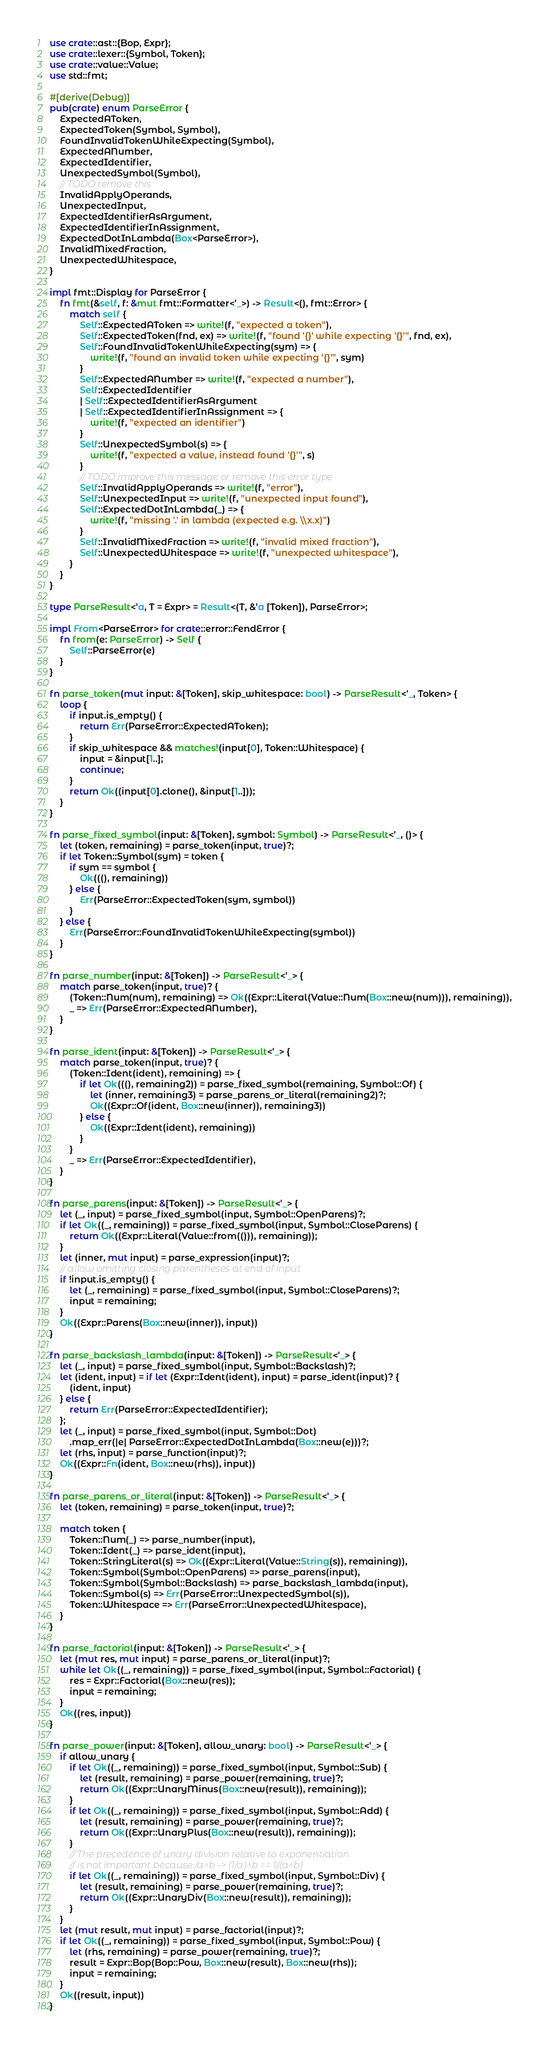Convert code to text. <code><loc_0><loc_0><loc_500><loc_500><_Rust_>use crate::ast::{Bop, Expr};
use crate::lexer::{Symbol, Token};
use crate::value::Value;
use std::fmt;

#[derive(Debug)]
pub(crate) enum ParseError {
    ExpectedAToken,
    ExpectedToken(Symbol, Symbol),
    FoundInvalidTokenWhileExpecting(Symbol),
    ExpectedANumber,
    ExpectedIdentifier,
    UnexpectedSymbol(Symbol),
    // TODO remove this
    InvalidApplyOperands,
    UnexpectedInput,
    ExpectedIdentifierAsArgument,
    ExpectedIdentifierInAssignment,
    ExpectedDotInLambda(Box<ParseError>),
    InvalidMixedFraction,
    UnexpectedWhitespace,
}

impl fmt::Display for ParseError {
    fn fmt(&self, f: &mut fmt::Formatter<'_>) -> Result<(), fmt::Error> {
        match self {
            Self::ExpectedAToken => write!(f, "expected a token"),
            Self::ExpectedToken(fnd, ex) => write!(f, "found '{}' while expecting '{}'", fnd, ex),
            Self::FoundInvalidTokenWhileExpecting(sym) => {
                write!(f, "found an invalid token while expecting '{}'", sym)
            }
            Self::ExpectedANumber => write!(f, "expected a number"),
            Self::ExpectedIdentifier
            | Self::ExpectedIdentifierAsArgument
            | Self::ExpectedIdentifierInAssignment => {
                write!(f, "expected an identifier")
            }
            Self::UnexpectedSymbol(s) => {
                write!(f, "expected a value, instead found '{}'", s)
            }
            // TODO improve this message or remove this error type
            Self::InvalidApplyOperands => write!(f, "error"),
            Self::UnexpectedInput => write!(f, "unexpected input found"),
            Self::ExpectedDotInLambda(_) => {
                write!(f, "missing '.' in lambda (expected e.g. \\x.x)")
            }
            Self::InvalidMixedFraction => write!(f, "invalid mixed fraction"),
            Self::UnexpectedWhitespace => write!(f, "unexpected whitespace"),
        }
    }
}

type ParseResult<'a, T = Expr> = Result<(T, &'a [Token]), ParseError>;

impl From<ParseError> for crate::error::FendError {
    fn from(e: ParseError) -> Self {
        Self::ParseError(e)
    }
}

fn parse_token(mut input: &[Token], skip_whitespace: bool) -> ParseResult<'_, Token> {
    loop {
        if input.is_empty() {
            return Err(ParseError::ExpectedAToken);
        }
        if skip_whitespace && matches!(input[0], Token::Whitespace) {
            input = &input[1..];
            continue;
        }
        return Ok((input[0].clone(), &input[1..]));
    }
}

fn parse_fixed_symbol(input: &[Token], symbol: Symbol) -> ParseResult<'_, ()> {
    let (token, remaining) = parse_token(input, true)?;
    if let Token::Symbol(sym) = token {
        if sym == symbol {
            Ok(((), remaining))
        } else {
            Err(ParseError::ExpectedToken(sym, symbol))
        }
    } else {
        Err(ParseError::FoundInvalidTokenWhileExpecting(symbol))
    }
}

fn parse_number(input: &[Token]) -> ParseResult<'_> {
    match parse_token(input, true)? {
        (Token::Num(num), remaining) => Ok((Expr::Literal(Value::Num(Box::new(num))), remaining)),
        _ => Err(ParseError::ExpectedANumber),
    }
}

fn parse_ident(input: &[Token]) -> ParseResult<'_> {
    match parse_token(input, true)? {
        (Token::Ident(ident), remaining) => {
            if let Ok(((), remaining2)) = parse_fixed_symbol(remaining, Symbol::Of) {
                let (inner, remaining3) = parse_parens_or_literal(remaining2)?;
                Ok((Expr::Of(ident, Box::new(inner)), remaining3))
            } else {
                Ok((Expr::Ident(ident), remaining))
            }
        }
        _ => Err(ParseError::ExpectedIdentifier),
    }
}

fn parse_parens(input: &[Token]) -> ParseResult<'_> {
    let (_, input) = parse_fixed_symbol(input, Symbol::OpenParens)?;
    if let Ok((_, remaining)) = parse_fixed_symbol(input, Symbol::CloseParens) {
        return Ok((Expr::Literal(Value::from(())), remaining));
    }
    let (inner, mut input) = parse_expression(input)?;
    // allow omitting closing parentheses at end of input
    if !input.is_empty() {
        let (_, remaining) = parse_fixed_symbol(input, Symbol::CloseParens)?;
        input = remaining;
    }
    Ok((Expr::Parens(Box::new(inner)), input))
}

fn parse_backslash_lambda(input: &[Token]) -> ParseResult<'_> {
    let (_, input) = parse_fixed_symbol(input, Symbol::Backslash)?;
    let (ident, input) = if let (Expr::Ident(ident), input) = parse_ident(input)? {
        (ident, input)
    } else {
        return Err(ParseError::ExpectedIdentifier);
    };
    let (_, input) = parse_fixed_symbol(input, Symbol::Dot)
        .map_err(|e| ParseError::ExpectedDotInLambda(Box::new(e)))?;
    let (rhs, input) = parse_function(input)?;
    Ok((Expr::Fn(ident, Box::new(rhs)), input))
}

fn parse_parens_or_literal(input: &[Token]) -> ParseResult<'_> {
    let (token, remaining) = parse_token(input, true)?;

    match token {
        Token::Num(_) => parse_number(input),
        Token::Ident(_) => parse_ident(input),
        Token::StringLiteral(s) => Ok((Expr::Literal(Value::String(s)), remaining)),
        Token::Symbol(Symbol::OpenParens) => parse_parens(input),
        Token::Symbol(Symbol::Backslash) => parse_backslash_lambda(input),
        Token::Symbol(s) => Err(ParseError::UnexpectedSymbol(s)),
        Token::Whitespace => Err(ParseError::UnexpectedWhitespace),
    }
}

fn parse_factorial(input: &[Token]) -> ParseResult<'_> {
    let (mut res, mut input) = parse_parens_or_literal(input)?;
    while let Ok((_, remaining)) = parse_fixed_symbol(input, Symbol::Factorial) {
        res = Expr::Factorial(Box::new(res));
        input = remaining;
    }
    Ok((res, input))
}

fn parse_power(input: &[Token], allow_unary: bool) -> ParseResult<'_> {
    if allow_unary {
        if let Ok((_, remaining)) = parse_fixed_symbol(input, Symbol::Sub) {
            let (result, remaining) = parse_power(remaining, true)?;
            return Ok((Expr::UnaryMinus(Box::new(result)), remaining));
        }
        if let Ok((_, remaining)) = parse_fixed_symbol(input, Symbol::Add) {
            let (result, remaining) = parse_power(remaining, true)?;
            return Ok((Expr::UnaryPlus(Box::new(result)), remaining));
        }
        // The precedence of unary division relative to exponentiation
        // is not important because /a^b -> (1/a)^b == 1/(a^b)
        if let Ok((_, remaining)) = parse_fixed_symbol(input, Symbol::Div) {
            let (result, remaining) = parse_power(remaining, true)?;
            return Ok((Expr::UnaryDiv(Box::new(result)), remaining));
        }
    }
    let (mut result, mut input) = parse_factorial(input)?;
    if let Ok((_, remaining)) = parse_fixed_symbol(input, Symbol::Pow) {
        let (rhs, remaining) = parse_power(remaining, true)?;
        result = Expr::Bop(Bop::Pow, Box::new(result), Box::new(rhs));
        input = remaining;
    }
    Ok((result, input))
}
</code> 